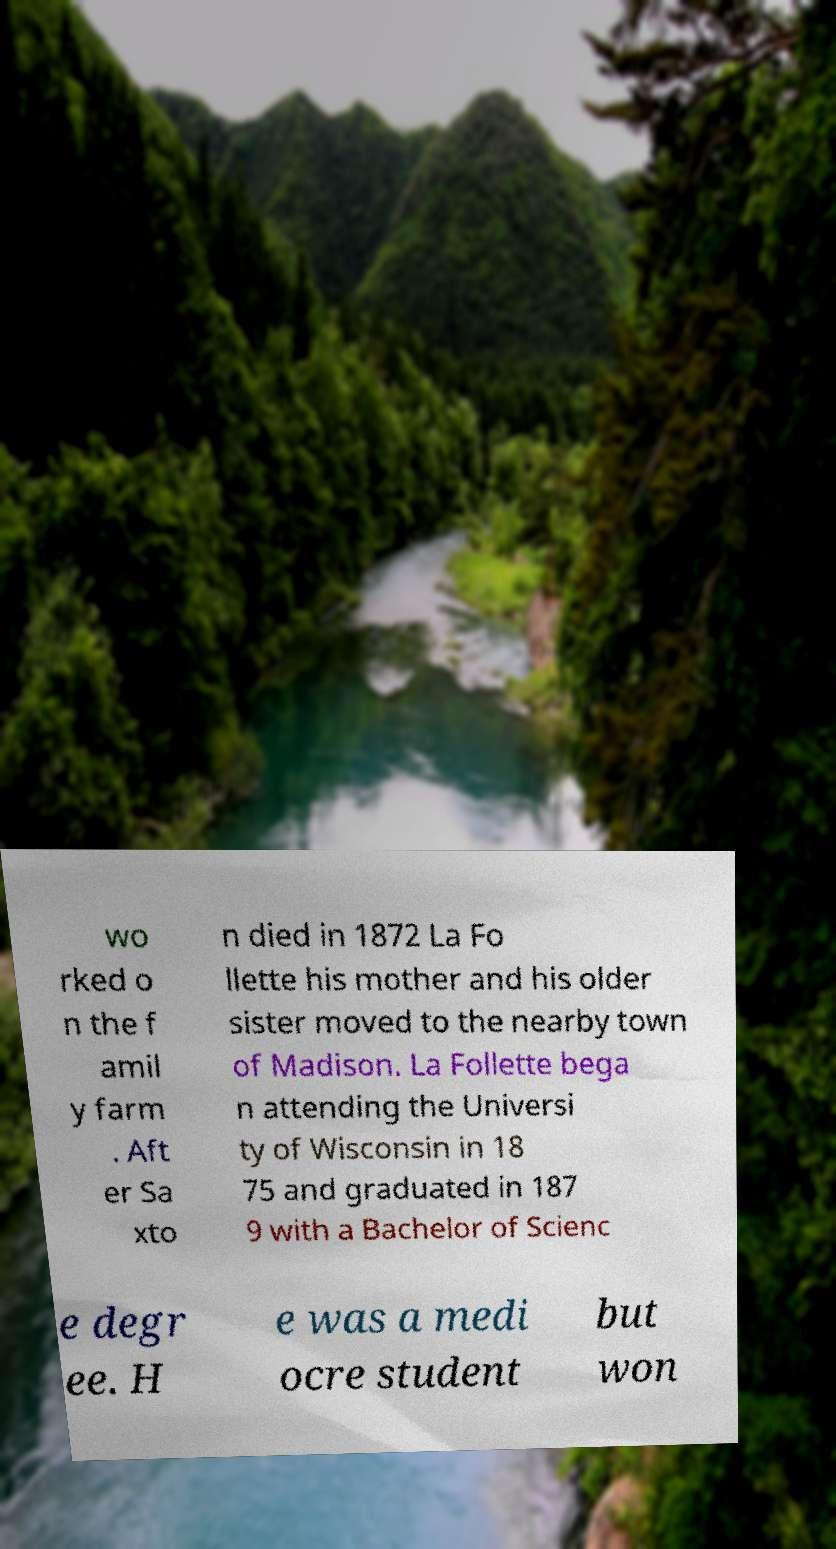Can you accurately transcribe the text from the provided image for me? wo rked o n the f amil y farm . Aft er Sa xto n died in 1872 La Fo llette his mother and his older sister moved to the nearby town of Madison. La Follette bega n attending the Universi ty of Wisconsin in 18 75 and graduated in 187 9 with a Bachelor of Scienc e degr ee. H e was a medi ocre student but won 